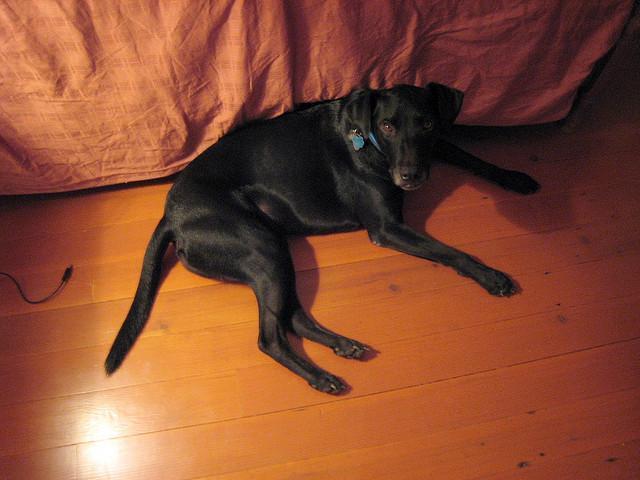How many clear glass bowls are on the counter?
Give a very brief answer. 0. 